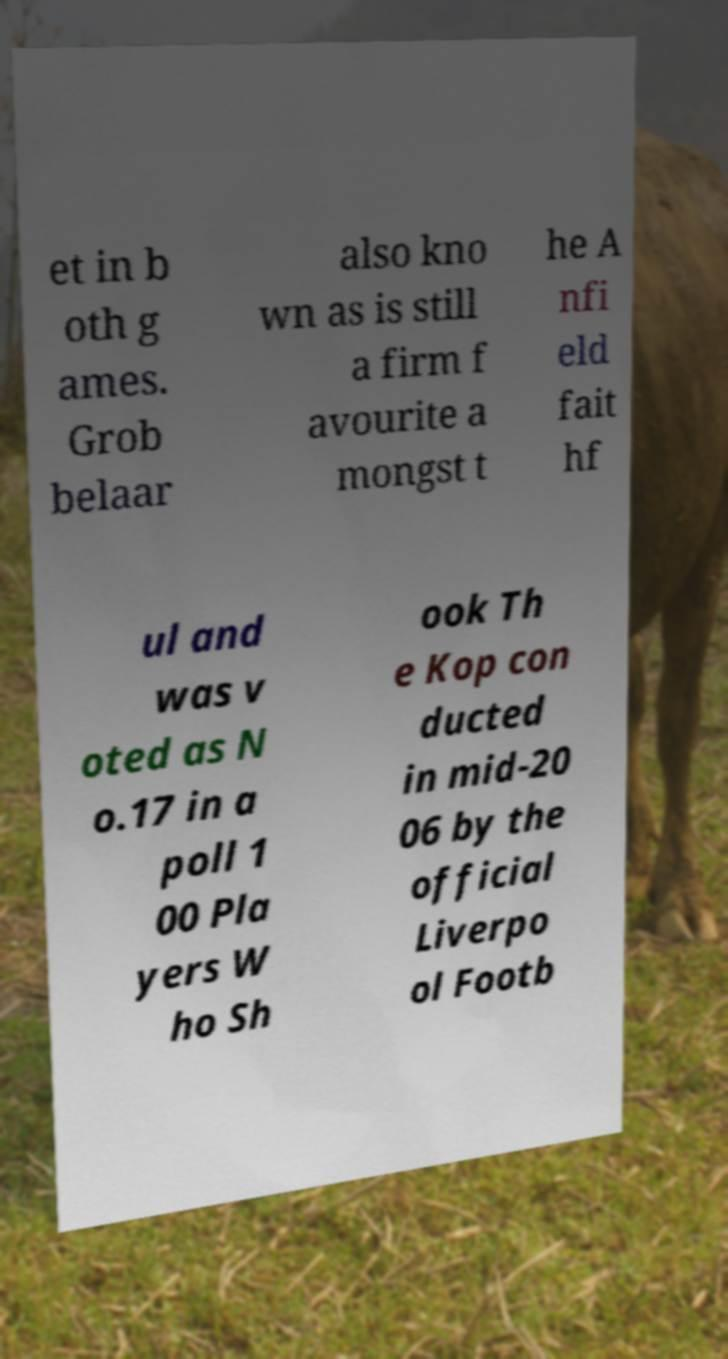Please read and relay the text visible in this image. What does it say? et in b oth g ames. Grob belaar also kno wn as is still a firm f avourite a mongst t he A nfi eld fait hf ul and was v oted as N o.17 in a poll 1 00 Pla yers W ho Sh ook Th e Kop con ducted in mid-20 06 by the official Liverpo ol Footb 